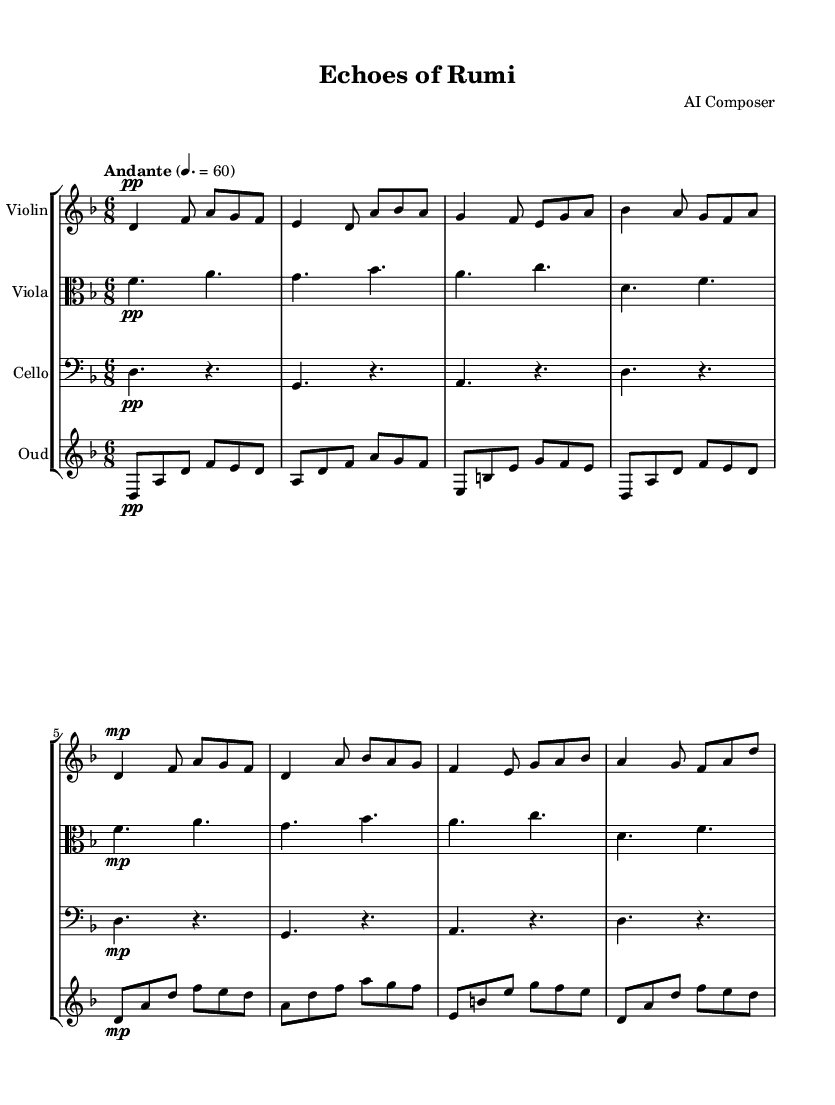What is the key signature of this music? The key signature is indicated at the beginning of the staff lines, showing two flats. This corresponds to D minor.
Answer: D minor What is the time signature of this piece? The time signature is located at the beginning of the score after the key signature, showing 6/8, indicating a compound meter with six eighth notes per measure.
Answer: 6/8 What is the tempo marking of the piece? The tempo marking appears above the score and is indicated as "Andante" with a metronome marking of 60, suggesting a moderate pace.
Answer: Andante, 60 How many measures are in the violin part? To determine the total number of measures, we count the measure bars in the violin music from start to finish. The violin part contains eight measures in total.
Answer: 8 What are the instruments featured in this chamber music? The instruments are labeled at the beginning of each staff: Violin, Viola, Cello, and Oud. Thus, there are four instruments in total.
Answer: Violin, Viola, Cello, Oud Which dynamic marking is primarily used throughout the piece? The dynamic marking at the beginning indicates "pp" (piano molto), which is primarily used in the music. This marking appears at the start of each instrument's part.
Answer: pp How does the rhythm of the oud music compare to the violin music? By analyzing the rhythmic structure, we can see that both parts utilize a 6/8 time signature, but the oud music contains shorter note values with a more fluid rhythmic pattern, whereas the violin music has a more defined phrasing.
Answer: Fluid 